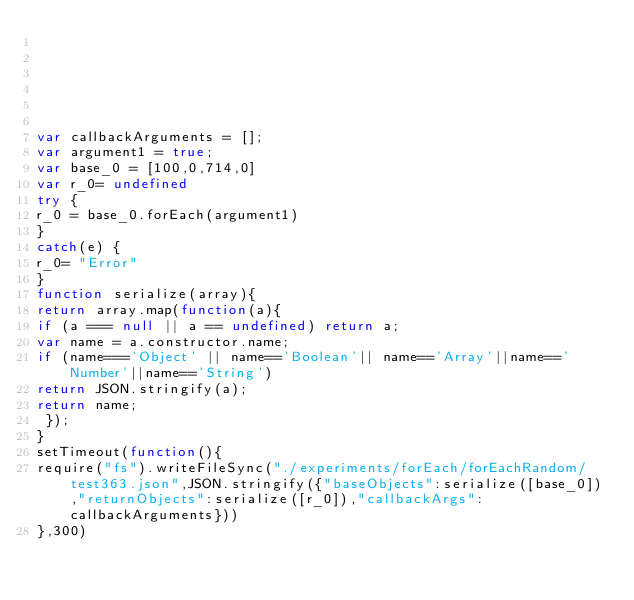Convert code to text. <code><loc_0><loc_0><loc_500><loc_500><_JavaScript_>





var callbackArguments = [];
var argument1 = true;
var base_0 = [100,0,714,0]
var r_0= undefined
try {
r_0 = base_0.forEach(argument1)
}
catch(e) {
r_0= "Error"
}
function serialize(array){
return array.map(function(a){
if (a === null || a == undefined) return a;
var name = a.constructor.name;
if (name==='Object' || name=='Boolean'|| name=='Array'||name=='Number'||name=='String')
return JSON.stringify(a);
return name;
 });
}
setTimeout(function(){
require("fs").writeFileSync("./experiments/forEach/forEachRandom/test363.json",JSON.stringify({"baseObjects":serialize([base_0]),"returnObjects":serialize([r_0]),"callbackArgs":callbackArguments}))
},300)</code> 